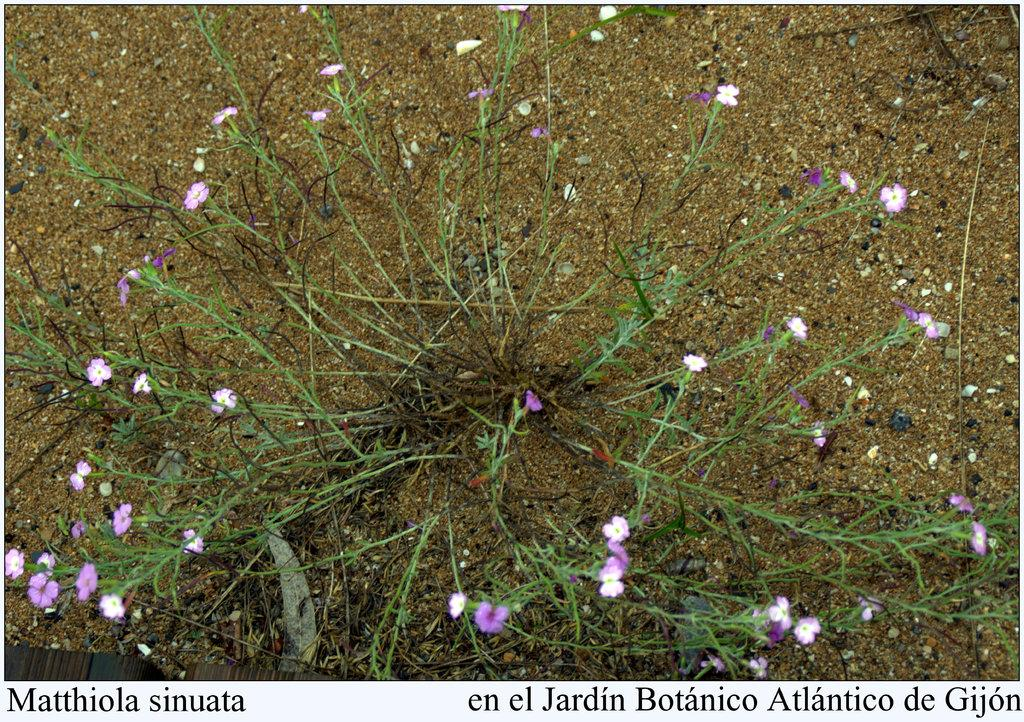What type of plant is visible in the image? There is a plant in the image. What additional features can be seen on the plant? There are flowers on the plant in the image. What type of surface is present in the image? There is sand in the image. What can be found at the bottom of the image? There is text at the bottom of the image. How many cobwebs are visible in the image? There are no cobwebs present in the image. What type of flag is flying in the background of the image? There is no flag visible in the image. 